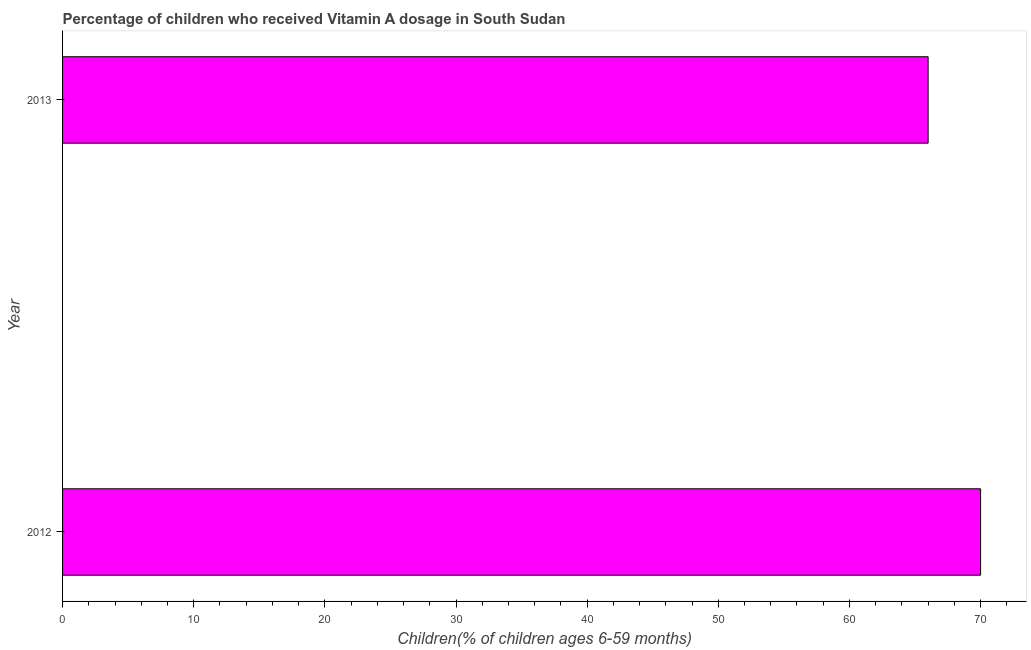Does the graph contain any zero values?
Your answer should be compact. No. What is the title of the graph?
Keep it short and to the point. Percentage of children who received Vitamin A dosage in South Sudan. What is the label or title of the X-axis?
Keep it short and to the point. Children(% of children ages 6-59 months). What is the label or title of the Y-axis?
Make the answer very short. Year. What is the vitamin a supplementation coverage rate in 2012?
Give a very brief answer. 70. Across all years, what is the minimum vitamin a supplementation coverage rate?
Make the answer very short. 66. What is the sum of the vitamin a supplementation coverage rate?
Your answer should be very brief. 136. What is the difference between the vitamin a supplementation coverage rate in 2012 and 2013?
Provide a succinct answer. 4. What is the average vitamin a supplementation coverage rate per year?
Offer a terse response. 68. Do a majority of the years between 2013 and 2012 (inclusive) have vitamin a supplementation coverage rate greater than 16 %?
Provide a short and direct response. No. What is the ratio of the vitamin a supplementation coverage rate in 2012 to that in 2013?
Your response must be concise. 1.06. Is the vitamin a supplementation coverage rate in 2012 less than that in 2013?
Offer a very short reply. No. In how many years, is the vitamin a supplementation coverage rate greater than the average vitamin a supplementation coverage rate taken over all years?
Ensure brevity in your answer.  1. How many years are there in the graph?
Offer a terse response. 2. What is the Children(% of children ages 6-59 months) in 2012?
Your answer should be very brief. 70. What is the Children(% of children ages 6-59 months) in 2013?
Keep it short and to the point. 66. What is the difference between the Children(% of children ages 6-59 months) in 2012 and 2013?
Offer a terse response. 4. What is the ratio of the Children(% of children ages 6-59 months) in 2012 to that in 2013?
Keep it short and to the point. 1.06. 